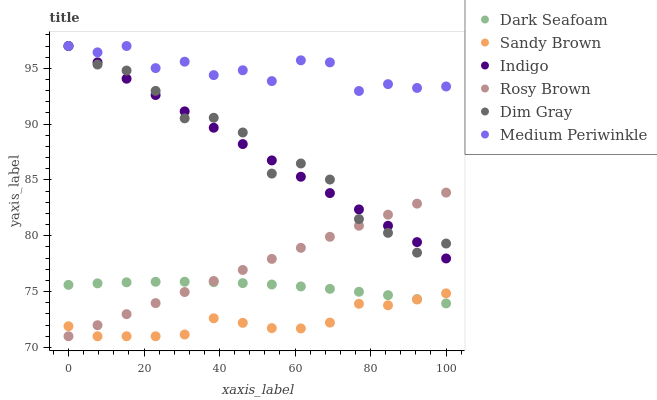Does Sandy Brown have the minimum area under the curve?
Answer yes or no. Yes. Does Medium Periwinkle have the maximum area under the curve?
Answer yes or no. Yes. Does Indigo have the minimum area under the curve?
Answer yes or no. No. Does Indigo have the maximum area under the curve?
Answer yes or no. No. Is Rosy Brown the smoothest?
Answer yes or no. Yes. Is Dim Gray the roughest?
Answer yes or no. Yes. Is Indigo the smoothest?
Answer yes or no. No. Is Indigo the roughest?
Answer yes or no. No. Does Rosy Brown have the lowest value?
Answer yes or no. Yes. Does Indigo have the lowest value?
Answer yes or no. No. Does Medium Periwinkle have the highest value?
Answer yes or no. Yes. Does Rosy Brown have the highest value?
Answer yes or no. No. Is Sandy Brown less than Dim Gray?
Answer yes or no. Yes. Is Medium Periwinkle greater than Rosy Brown?
Answer yes or no. Yes. Does Dim Gray intersect Indigo?
Answer yes or no. Yes. Is Dim Gray less than Indigo?
Answer yes or no. No. Is Dim Gray greater than Indigo?
Answer yes or no. No. Does Sandy Brown intersect Dim Gray?
Answer yes or no. No. 